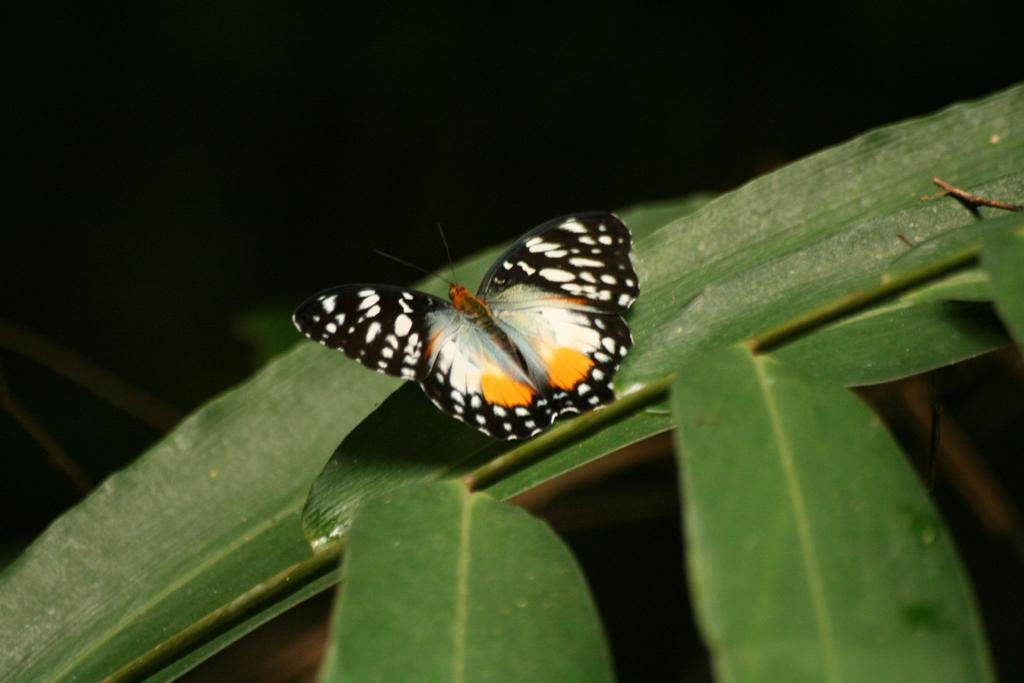What is the main subject of the image? There is a butterfly in the image. Where is the butterfly located? The butterfly is on leaves. What is the color of the background in the image? The background of the image is black. What route does the car take in the image? There is no car present in the image, so it is not possible to determine a route. 